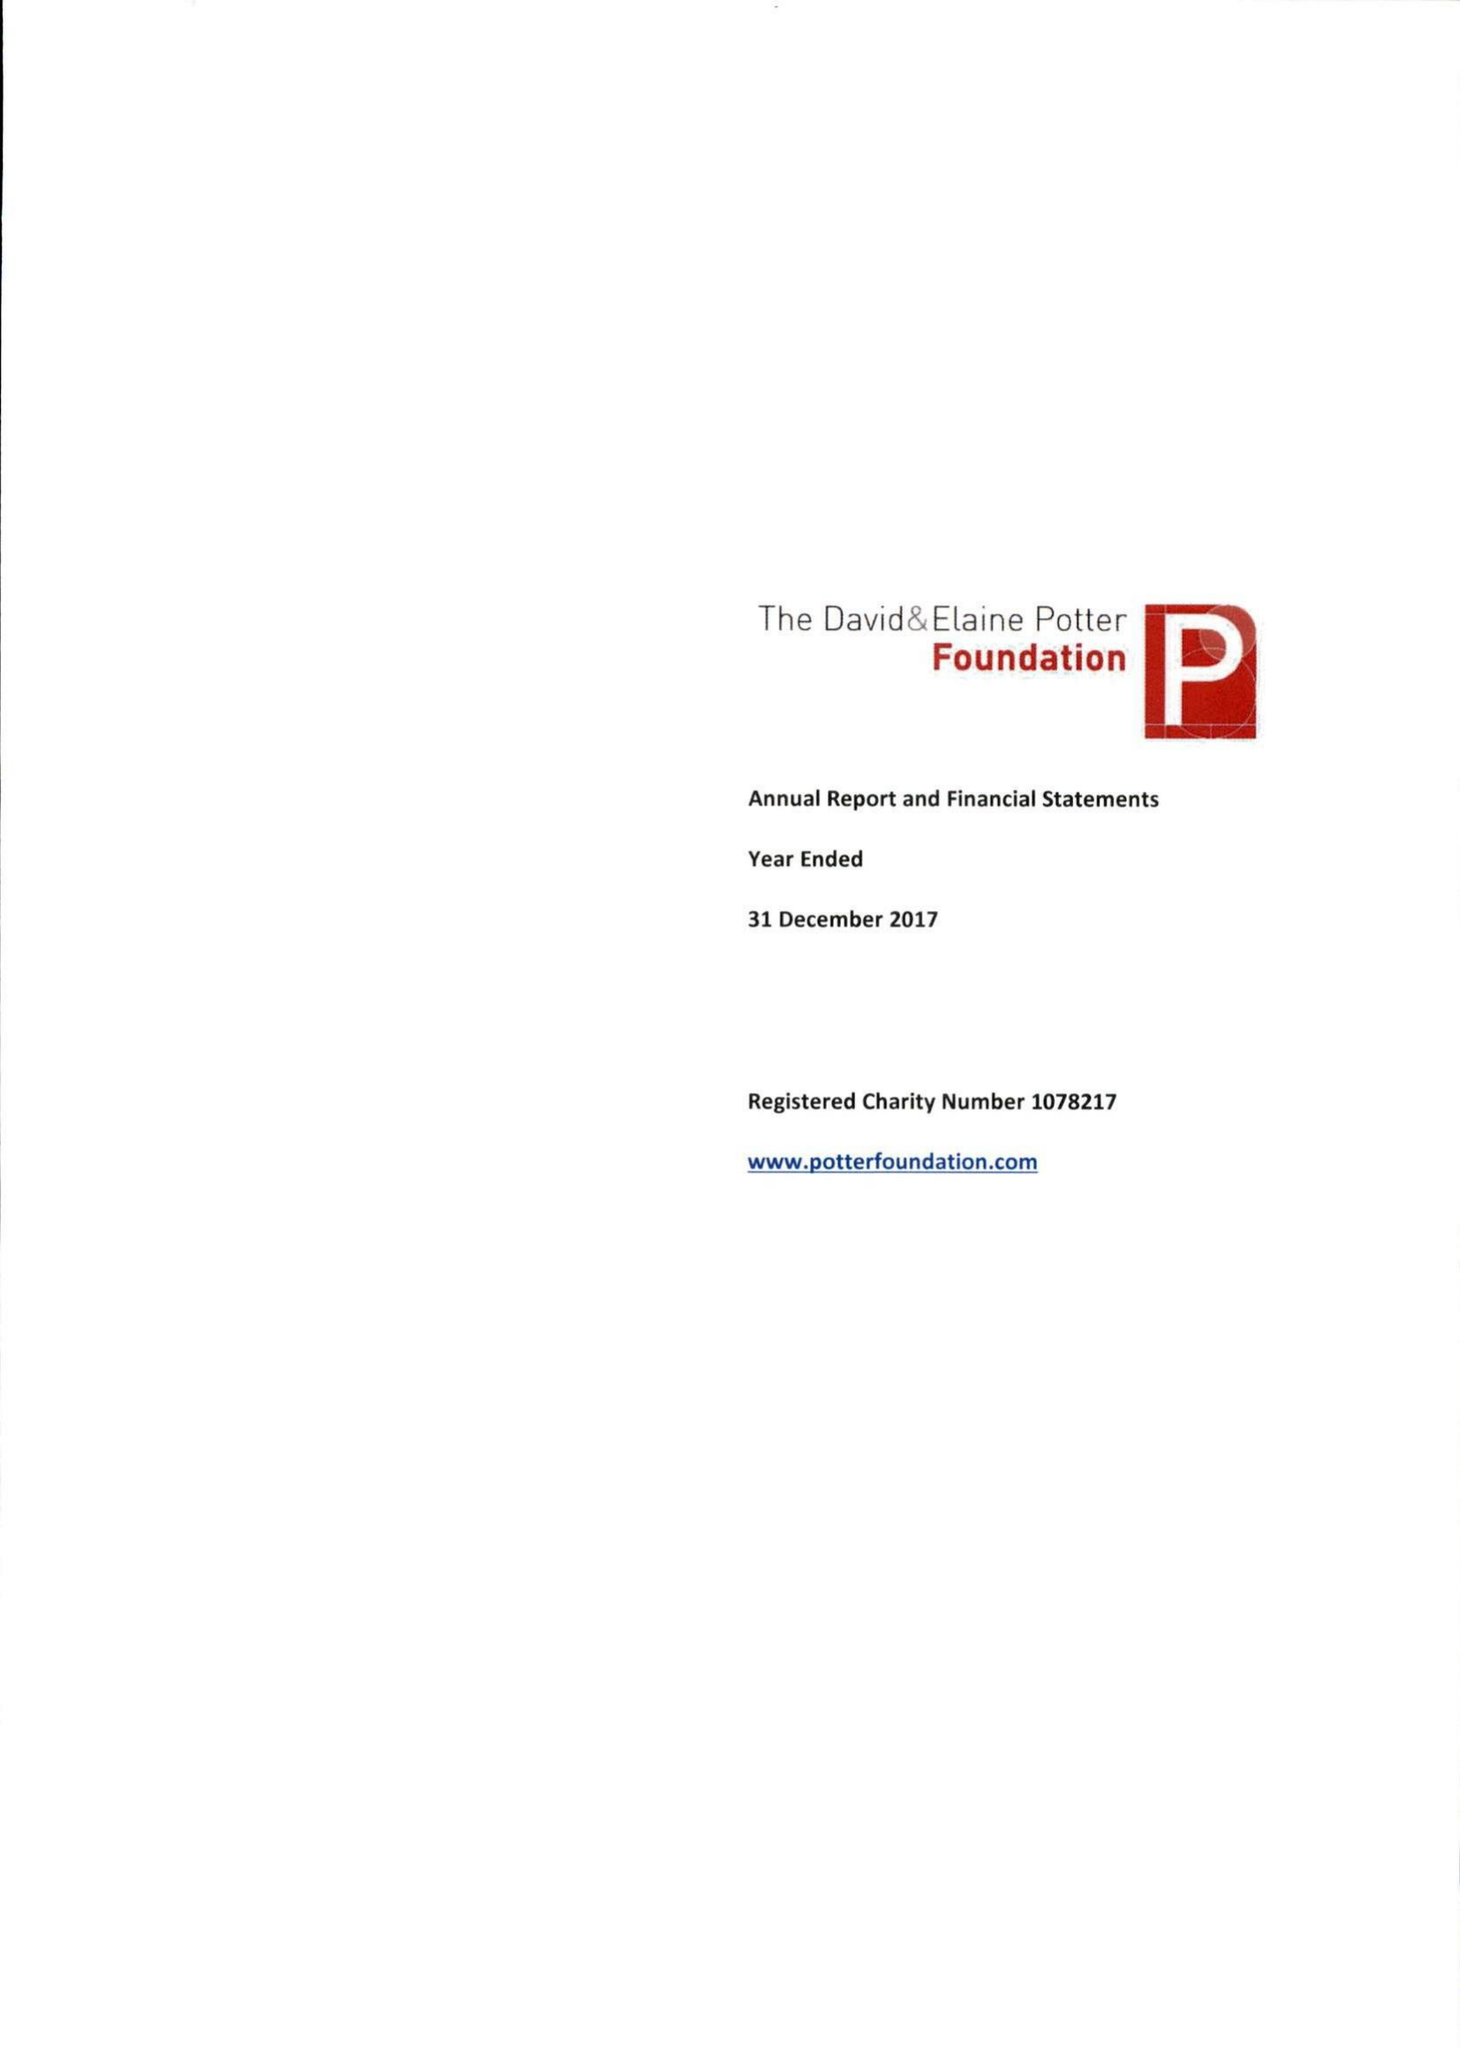What is the value for the charity_number?
Answer the question using a single word or phrase. 1078217 